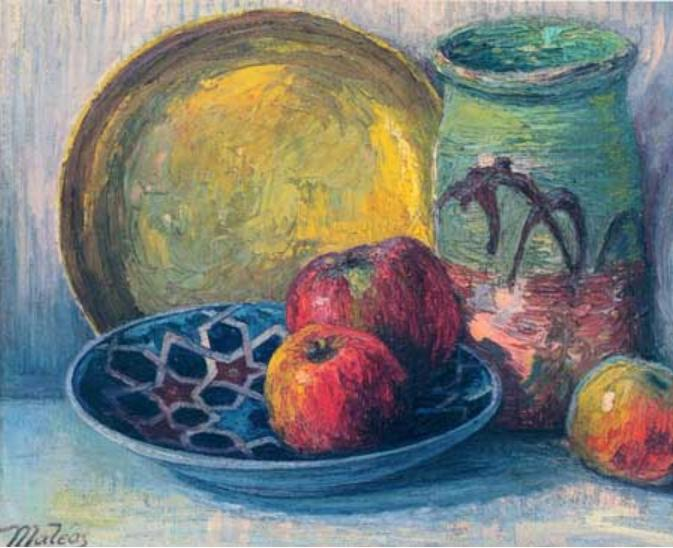Can you create a story based on the elements in this painting? Once upon a time in a quaint countryside cottage, an artist named Mateo lived a serene life surrounded by nature's bounty. One sunny morning, as rays of golden sunlight filtered through the kitchen window, Mateo felt a surge of inspiration. He decided to capture a moment of his peaceful existence through his art.

He carefully arranged a few apples he had picked from the orchard into a blue, intricately designed bowl— a precious family heirloom. Next to it, he placed a green ceramic vase that he had molded with his own hands, adorned with abstract patterns reminiscent of the wild vines that grew around his home. To complete the scene, he positioned a rustic yellow plate, its warm hue echoing the sunflower fields nearby.

As Mateo worked, he reminisced about the simplicity and joy of his daily life. Each brushstroke he laid on the canvas was a reflection of his love for the little moments— the quiet breakfasts, the scent of apples, the texture of pottery. His painting, full of color and life, was a celebration of the mundane yet beautiful moments that made his world so rich and meaningful.

And so, Mateo's still life painting became more than just a visual feast; it was a heartfelt tribute to the everyday joys that nourished his soul. 